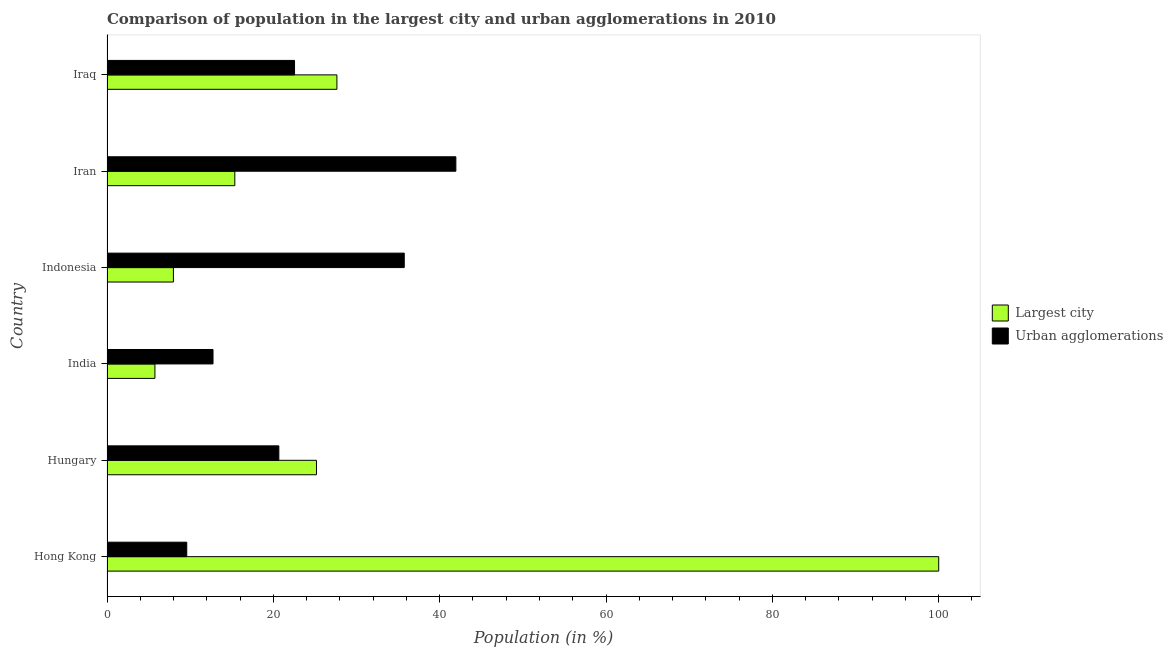How many different coloured bars are there?
Offer a terse response. 2. How many bars are there on the 3rd tick from the top?
Make the answer very short. 2. How many bars are there on the 4th tick from the bottom?
Offer a very short reply. 2. What is the label of the 2nd group of bars from the top?
Your response must be concise. Iran. In how many cases, is the number of bars for a given country not equal to the number of legend labels?
Give a very brief answer. 0. What is the population in the largest city in India?
Offer a very short reply. 5.76. Across all countries, what is the maximum population in urban agglomerations?
Offer a very short reply. 41.95. Across all countries, what is the minimum population in the largest city?
Keep it short and to the point. 5.76. In which country was the population in urban agglomerations maximum?
Give a very brief answer. Iran. In which country was the population in the largest city minimum?
Provide a short and direct response. India. What is the total population in urban agglomerations in the graph?
Offer a terse response. 143.23. What is the difference between the population in urban agglomerations in Hungary and that in Iraq?
Your answer should be very brief. -1.89. What is the difference between the population in the largest city in Iran and the population in urban agglomerations in India?
Your answer should be compact. 2.62. What is the average population in the largest city per country?
Offer a very short reply. 30.32. What is the difference between the population in the largest city and population in urban agglomerations in Hong Kong?
Ensure brevity in your answer.  90.41. In how many countries, is the population in urban agglomerations greater than 76 %?
Your response must be concise. 0. What is the ratio of the population in the largest city in Indonesia to that in Iran?
Keep it short and to the point. 0.52. Is the population in urban agglomerations in India less than that in Iraq?
Give a very brief answer. Yes. What is the difference between the highest and the second highest population in urban agglomerations?
Give a very brief answer. 6.21. What is the difference between the highest and the lowest population in urban agglomerations?
Provide a succinct answer. 32.36. In how many countries, is the population in the largest city greater than the average population in the largest city taken over all countries?
Your answer should be very brief. 1. Is the sum of the population in the largest city in Indonesia and Iran greater than the maximum population in urban agglomerations across all countries?
Make the answer very short. No. What does the 1st bar from the top in Iran represents?
Your answer should be very brief. Urban agglomerations. What does the 1st bar from the bottom in Hungary represents?
Your answer should be compact. Largest city. How many countries are there in the graph?
Your answer should be very brief. 6. Are the values on the major ticks of X-axis written in scientific E-notation?
Your answer should be very brief. No. Does the graph contain grids?
Provide a succinct answer. No. Where does the legend appear in the graph?
Offer a terse response. Center right. How many legend labels are there?
Your response must be concise. 2. What is the title of the graph?
Ensure brevity in your answer.  Comparison of population in the largest city and urban agglomerations in 2010. Does "Investment" appear as one of the legend labels in the graph?
Give a very brief answer. No. What is the label or title of the X-axis?
Your answer should be very brief. Population (in %). What is the Population (in %) in Largest city in Hong Kong?
Your response must be concise. 100. What is the Population (in %) in Urban agglomerations in Hong Kong?
Provide a succinct answer. 9.59. What is the Population (in %) in Largest city in Hungary?
Give a very brief answer. 25.19. What is the Population (in %) of Urban agglomerations in Hungary?
Provide a short and direct response. 20.66. What is the Population (in %) in Largest city in India?
Provide a succinct answer. 5.76. What is the Population (in %) of Urban agglomerations in India?
Offer a very short reply. 12.75. What is the Population (in %) in Largest city in Indonesia?
Your response must be concise. 7.98. What is the Population (in %) of Urban agglomerations in Indonesia?
Your answer should be compact. 35.74. What is the Population (in %) of Largest city in Iran?
Provide a succinct answer. 15.37. What is the Population (in %) of Urban agglomerations in Iran?
Your answer should be very brief. 41.95. What is the Population (in %) in Largest city in Iraq?
Your answer should be compact. 27.64. What is the Population (in %) of Urban agglomerations in Iraq?
Keep it short and to the point. 22.55. Across all countries, what is the maximum Population (in %) of Largest city?
Ensure brevity in your answer.  100. Across all countries, what is the maximum Population (in %) of Urban agglomerations?
Make the answer very short. 41.95. Across all countries, what is the minimum Population (in %) of Largest city?
Provide a succinct answer. 5.76. Across all countries, what is the minimum Population (in %) of Urban agglomerations?
Keep it short and to the point. 9.59. What is the total Population (in %) of Largest city in the graph?
Provide a short and direct response. 181.94. What is the total Population (in %) in Urban agglomerations in the graph?
Offer a very short reply. 143.23. What is the difference between the Population (in %) of Largest city in Hong Kong and that in Hungary?
Offer a very short reply. 74.81. What is the difference between the Population (in %) of Urban agglomerations in Hong Kong and that in Hungary?
Make the answer very short. -11.07. What is the difference between the Population (in %) of Largest city in Hong Kong and that in India?
Your answer should be compact. 94.24. What is the difference between the Population (in %) of Urban agglomerations in Hong Kong and that in India?
Make the answer very short. -3.16. What is the difference between the Population (in %) in Largest city in Hong Kong and that in Indonesia?
Your response must be concise. 92.02. What is the difference between the Population (in %) in Urban agglomerations in Hong Kong and that in Indonesia?
Offer a terse response. -26.15. What is the difference between the Population (in %) of Largest city in Hong Kong and that in Iran?
Keep it short and to the point. 84.63. What is the difference between the Population (in %) in Urban agglomerations in Hong Kong and that in Iran?
Provide a succinct answer. -32.36. What is the difference between the Population (in %) in Largest city in Hong Kong and that in Iraq?
Offer a terse response. 72.36. What is the difference between the Population (in %) in Urban agglomerations in Hong Kong and that in Iraq?
Offer a terse response. -12.96. What is the difference between the Population (in %) of Largest city in Hungary and that in India?
Your response must be concise. 19.43. What is the difference between the Population (in %) of Urban agglomerations in Hungary and that in India?
Your answer should be compact. 7.91. What is the difference between the Population (in %) in Largest city in Hungary and that in Indonesia?
Give a very brief answer. 17.2. What is the difference between the Population (in %) in Urban agglomerations in Hungary and that in Indonesia?
Your answer should be compact. -15.08. What is the difference between the Population (in %) in Largest city in Hungary and that in Iran?
Your response must be concise. 9.82. What is the difference between the Population (in %) of Urban agglomerations in Hungary and that in Iran?
Your answer should be very brief. -21.28. What is the difference between the Population (in %) in Largest city in Hungary and that in Iraq?
Ensure brevity in your answer.  -2.46. What is the difference between the Population (in %) in Urban agglomerations in Hungary and that in Iraq?
Ensure brevity in your answer.  -1.89. What is the difference between the Population (in %) in Largest city in India and that in Indonesia?
Provide a succinct answer. -2.22. What is the difference between the Population (in %) of Urban agglomerations in India and that in Indonesia?
Make the answer very short. -22.99. What is the difference between the Population (in %) in Largest city in India and that in Iran?
Keep it short and to the point. -9.61. What is the difference between the Population (in %) of Urban agglomerations in India and that in Iran?
Offer a terse response. -29.2. What is the difference between the Population (in %) of Largest city in India and that in Iraq?
Keep it short and to the point. -21.88. What is the difference between the Population (in %) of Urban agglomerations in India and that in Iraq?
Offer a terse response. -9.8. What is the difference between the Population (in %) in Largest city in Indonesia and that in Iran?
Your response must be concise. -7.38. What is the difference between the Population (in %) in Urban agglomerations in Indonesia and that in Iran?
Provide a succinct answer. -6.21. What is the difference between the Population (in %) in Largest city in Indonesia and that in Iraq?
Your response must be concise. -19.66. What is the difference between the Population (in %) in Urban agglomerations in Indonesia and that in Iraq?
Keep it short and to the point. 13.19. What is the difference between the Population (in %) in Largest city in Iran and that in Iraq?
Provide a short and direct response. -12.28. What is the difference between the Population (in %) of Urban agglomerations in Iran and that in Iraq?
Provide a short and direct response. 19.4. What is the difference between the Population (in %) of Largest city in Hong Kong and the Population (in %) of Urban agglomerations in Hungary?
Offer a very short reply. 79.34. What is the difference between the Population (in %) of Largest city in Hong Kong and the Population (in %) of Urban agglomerations in India?
Your response must be concise. 87.25. What is the difference between the Population (in %) in Largest city in Hong Kong and the Population (in %) in Urban agglomerations in Indonesia?
Offer a terse response. 64.26. What is the difference between the Population (in %) of Largest city in Hong Kong and the Population (in %) of Urban agglomerations in Iran?
Ensure brevity in your answer.  58.05. What is the difference between the Population (in %) of Largest city in Hong Kong and the Population (in %) of Urban agglomerations in Iraq?
Make the answer very short. 77.45. What is the difference between the Population (in %) of Largest city in Hungary and the Population (in %) of Urban agglomerations in India?
Your answer should be very brief. 12.44. What is the difference between the Population (in %) of Largest city in Hungary and the Population (in %) of Urban agglomerations in Indonesia?
Your answer should be very brief. -10.55. What is the difference between the Population (in %) in Largest city in Hungary and the Population (in %) in Urban agglomerations in Iran?
Ensure brevity in your answer.  -16.76. What is the difference between the Population (in %) in Largest city in Hungary and the Population (in %) in Urban agglomerations in Iraq?
Your answer should be very brief. 2.64. What is the difference between the Population (in %) in Largest city in India and the Population (in %) in Urban agglomerations in Indonesia?
Your answer should be very brief. -29.98. What is the difference between the Population (in %) of Largest city in India and the Population (in %) of Urban agglomerations in Iran?
Your answer should be compact. -36.18. What is the difference between the Population (in %) in Largest city in India and the Population (in %) in Urban agglomerations in Iraq?
Your answer should be very brief. -16.79. What is the difference between the Population (in %) in Largest city in Indonesia and the Population (in %) in Urban agglomerations in Iran?
Offer a very short reply. -33.96. What is the difference between the Population (in %) in Largest city in Indonesia and the Population (in %) in Urban agglomerations in Iraq?
Ensure brevity in your answer.  -14.56. What is the difference between the Population (in %) in Largest city in Iran and the Population (in %) in Urban agglomerations in Iraq?
Offer a very short reply. -7.18. What is the average Population (in %) of Largest city per country?
Ensure brevity in your answer.  30.32. What is the average Population (in %) of Urban agglomerations per country?
Make the answer very short. 23.87. What is the difference between the Population (in %) of Largest city and Population (in %) of Urban agglomerations in Hong Kong?
Your answer should be compact. 90.41. What is the difference between the Population (in %) in Largest city and Population (in %) in Urban agglomerations in Hungary?
Your answer should be compact. 4.53. What is the difference between the Population (in %) in Largest city and Population (in %) in Urban agglomerations in India?
Provide a short and direct response. -6.99. What is the difference between the Population (in %) of Largest city and Population (in %) of Urban agglomerations in Indonesia?
Make the answer very short. -27.76. What is the difference between the Population (in %) in Largest city and Population (in %) in Urban agglomerations in Iran?
Keep it short and to the point. -26.58. What is the difference between the Population (in %) in Largest city and Population (in %) in Urban agglomerations in Iraq?
Give a very brief answer. 5.1. What is the ratio of the Population (in %) in Largest city in Hong Kong to that in Hungary?
Offer a terse response. 3.97. What is the ratio of the Population (in %) in Urban agglomerations in Hong Kong to that in Hungary?
Offer a terse response. 0.46. What is the ratio of the Population (in %) of Largest city in Hong Kong to that in India?
Give a very brief answer. 17.36. What is the ratio of the Population (in %) of Urban agglomerations in Hong Kong to that in India?
Your response must be concise. 0.75. What is the ratio of the Population (in %) in Largest city in Hong Kong to that in Indonesia?
Keep it short and to the point. 12.53. What is the ratio of the Population (in %) in Urban agglomerations in Hong Kong to that in Indonesia?
Make the answer very short. 0.27. What is the ratio of the Population (in %) of Largest city in Hong Kong to that in Iran?
Give a very brief answer. 6.51. What is the ratio of the Population (in %) in Urban agglomerations in Hong Kong to that in Iran?
Ensure brevity in your answer.  0.23. What is the ratio of the Population (in %) of Largest city in Hong Kong to that in Iraq?
Give a very brief answer. 3.62. What is the ratio of the Population (in %) in Urban agglomerations in Hong Kong to that in Iraq?
Provide a succinct answer. 0.43. What is the ratio of the Population (in %) in Largest city in Hungary to that in India?
Ensure brevity in your answer.  4.37. What is the ratio of the Population (in %) of Urban agglomerations in Hungary to that in India?
Give a very brief answer. 1.62. What is the ratio of the Population (in %) of Largest city in Hungary to that in Indonesia?
Offer a terse response. 3.15. What is the ratio of the Population (in %) of Urban agglomerations in Hungary to that in Indonesia?
Your response must be concise. 0.58. What is the ratio of the Population (in %) of Largest city in Hungary to that in Iran?
Make the answer very short. 1.64. What is the ratio of the Population (in %) in Urban agglomerations in Hungary to that in Iran?
Your response must be concise. 0.49. What is the ratio of the Population (in %) in Largest city in Hungary to that in Iraq?
Your answer should be compact. 0.91. What is the ratio of the Population (in %) in Urban agglomerations in Hungary to that in Iraq?
Your answer should be very brief. 0.92. What is the ratio of the Population (in %) of Largest city in India to that in Indonesia?
Your answer should be very brief. 0.72. What is the ratio of the Population (in %) in Urban agglomerations in India to that in Indonesia?
Offer a very short reply. 0.36. What is the ratio of the Population (in %) of Largest city in India to that in Iran?
Offer a very short reply. 0.37. What is the ratio of the Population (in %) in Urban agglomerations in India to that in Iran?
Ensure brevity in your answer.  0.3. What is the ratio of the Population (in %) of Largest city in India to that in Iraq?
Offer a terse response. 0.21. What is the ratio of the Population (in %) of Urban agglomerations in India to that in Iraq?
Ensure brevity in your answer.  0.57. What is the ratio of the Population (in %) of Largest city in Indonesia to that in Iran?
Offer a very short reply. 0.52. What is the ratio of the Population (in %) of Urban agglomerations in Indonesia to that in Iran?
Provide a succinct answer. 0.85. What is the ratio of the Population (in %) of Largest city in Indonesia to that in Iraq?
Provide a short and direct response. 0.29. What is the ratio of the Population (in %) of Urban agglomerations in Indonesia to that in Iraq?
Your answer should be very brief. 1.59. What is the ratio of the Population (in %) in Largest city in Iran to that in Iraq?
Offer a terse response. 0.56. What is the ratio of the Population (in %) of Urban agglomerations in Iran to that in Iraq?
Offer a terse response. 1.86. What is the difference between the highest and the second highest Population (in %) in Largest city?
Make the answer very short. 72.36. What is the difference between the highest and the second highest Population (in %) of Urban agglomerations?
Provide a succinct answer. 6.21. What is the difference between the highest and the lowest Population (in %) in Largest city?
Offer a terse response. 94.24. What is the difference between the highest and the lowest Population (in %) in Urban agglomerations?
Your response must be concise. 32.36. 